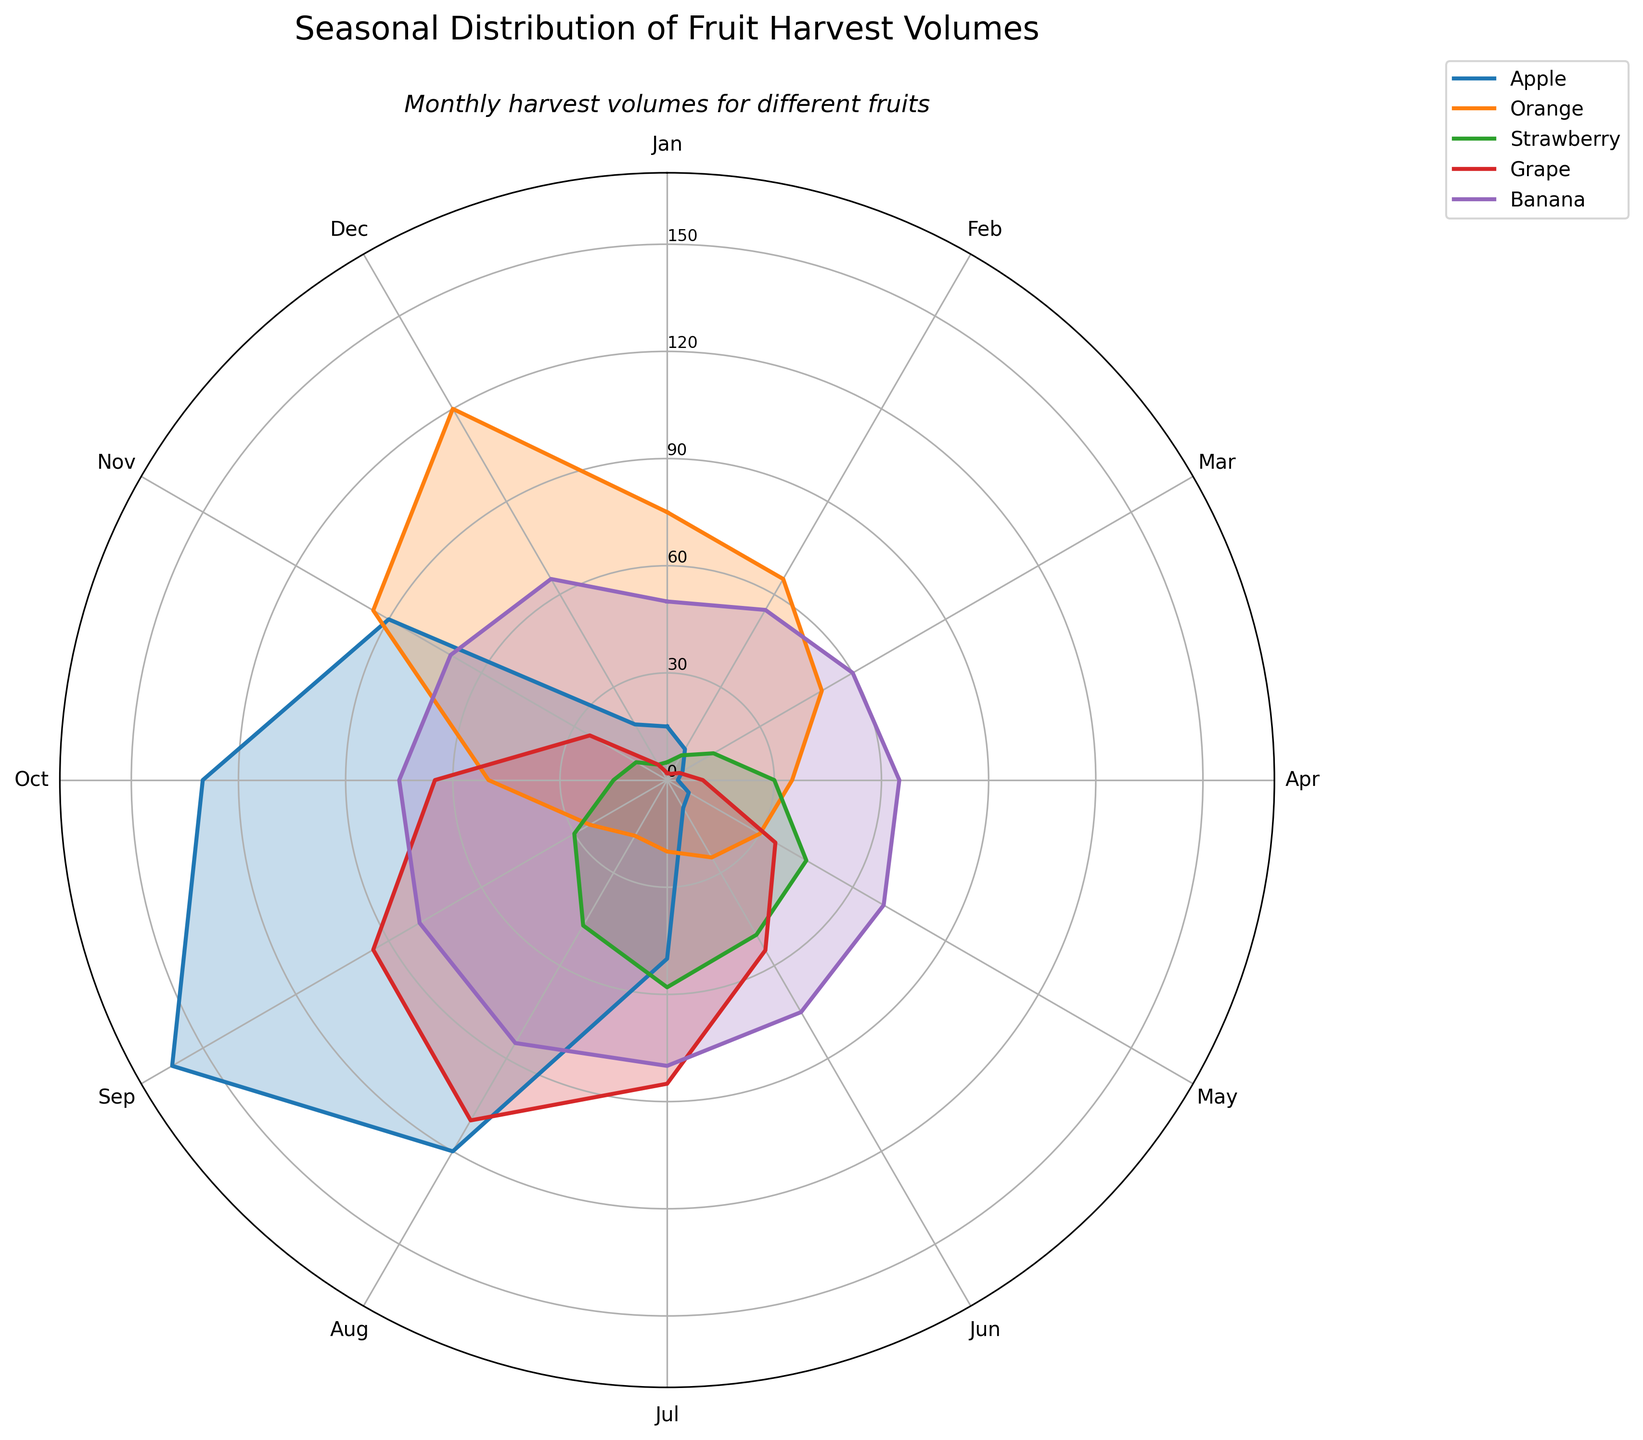What is the title of the rose chart? The title is the text displayed at the top of the chart. In this case, it is mentioned in the code.
Answer: Seasonal Distribution of Fruit Harvest Volumes What month has the highest harvest volume for apples? Identify the segment that extends the furthest from the center for apples (usually marked with a color or label). The segment corresponding to September is the longest for apples in the figure.
Answer: September Which fruit has the most consistent harvest volume throughout the year? Look for the fruit whose values are most evenly distributed around the circle without large peaks or valleys. The banana has a nearly constant value throughout all months.
Answer: Banana In which months do strawberries have a harvest volume of at least 45? Identify months where the strawberry line extends above the 45 unit mark. These months are May, June, and July.
Answer: May, June, and July How does the harvest volume of oranges in December compare to that of apples in September? Check the segments for oranges in December and apples in September. Both segments extend to the same length.
Answer: They are equal Which fruit has the lowest harvest volume in January? Compare the lengths of the segments for each fruit in January. Grapes have the shortest segment in January.
Answer: Grape If you sum the harvest volumes of apples in July and August, how does it compare to the harvest volume of strawberries in June and July combined? Add the volumes for apples: 50 (July) + 120 (August) = 170. Add the volumes for strawberries: 50 (June) + 58 (July) = 108. Compare the two sums. 170 is greater than 108.
Answer: Apples' total is greater What is the range of the harvest volume for grapes? Identify the maximum and minimum values for grapes. The highest is 110 (August) and the lowest is 2 (multiple months). Subtract the minimum from the maximum: 110 - 2 = 108.
Answer: 108 Which month sees the peak harvest for strawberries? Look for the month where the strawberries' line is the longest. July has the longest segment for strawberries.
Answer: July 